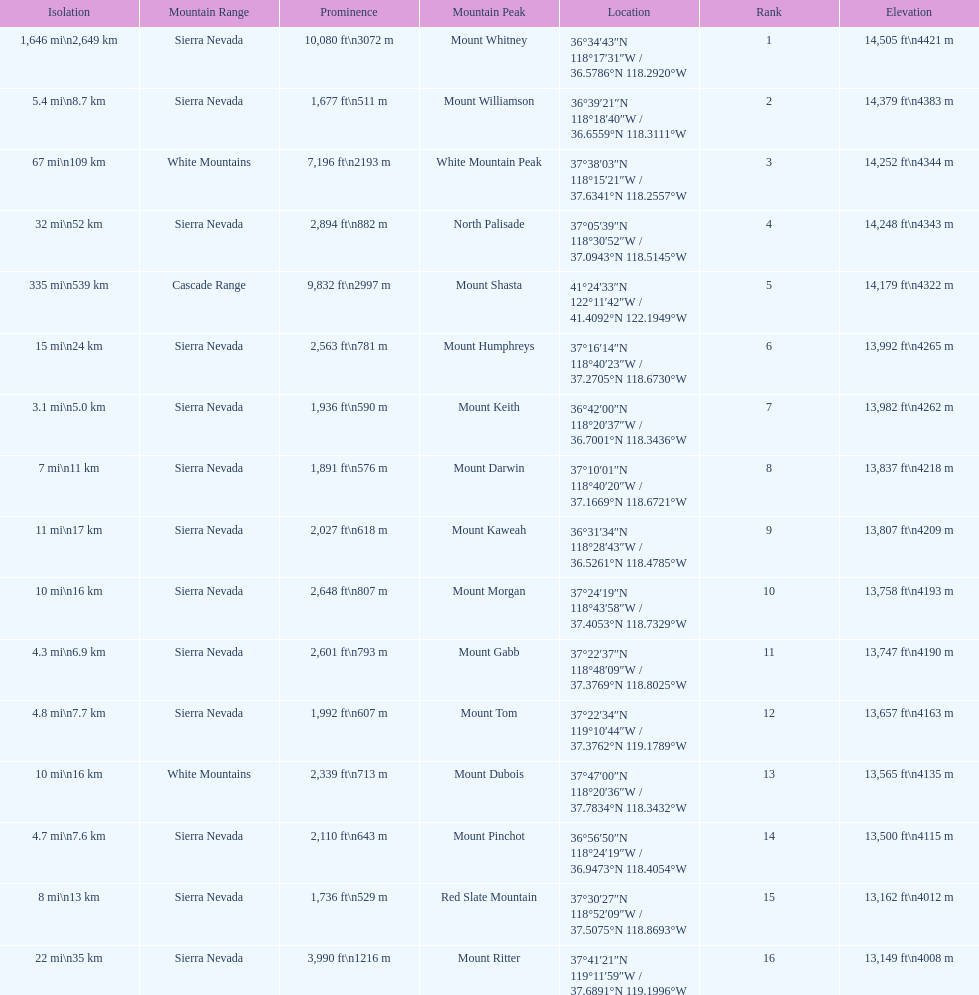Which mountain peak is no higher than 13,149 ft? Mount Ritter. 